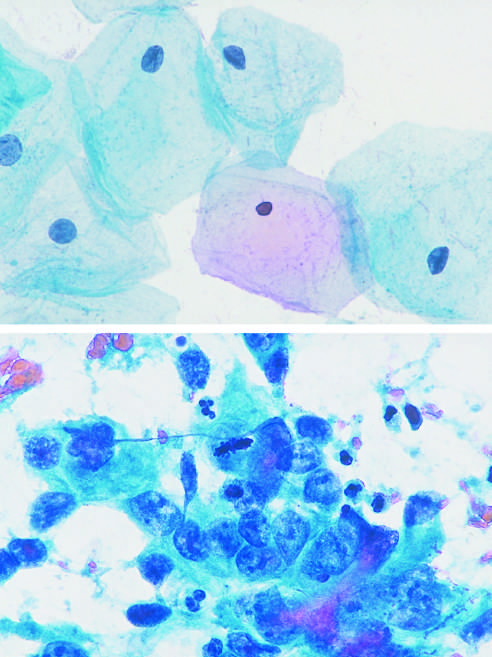s atrophy of the brain evident?
Answer the question using a single word or phrase. No 